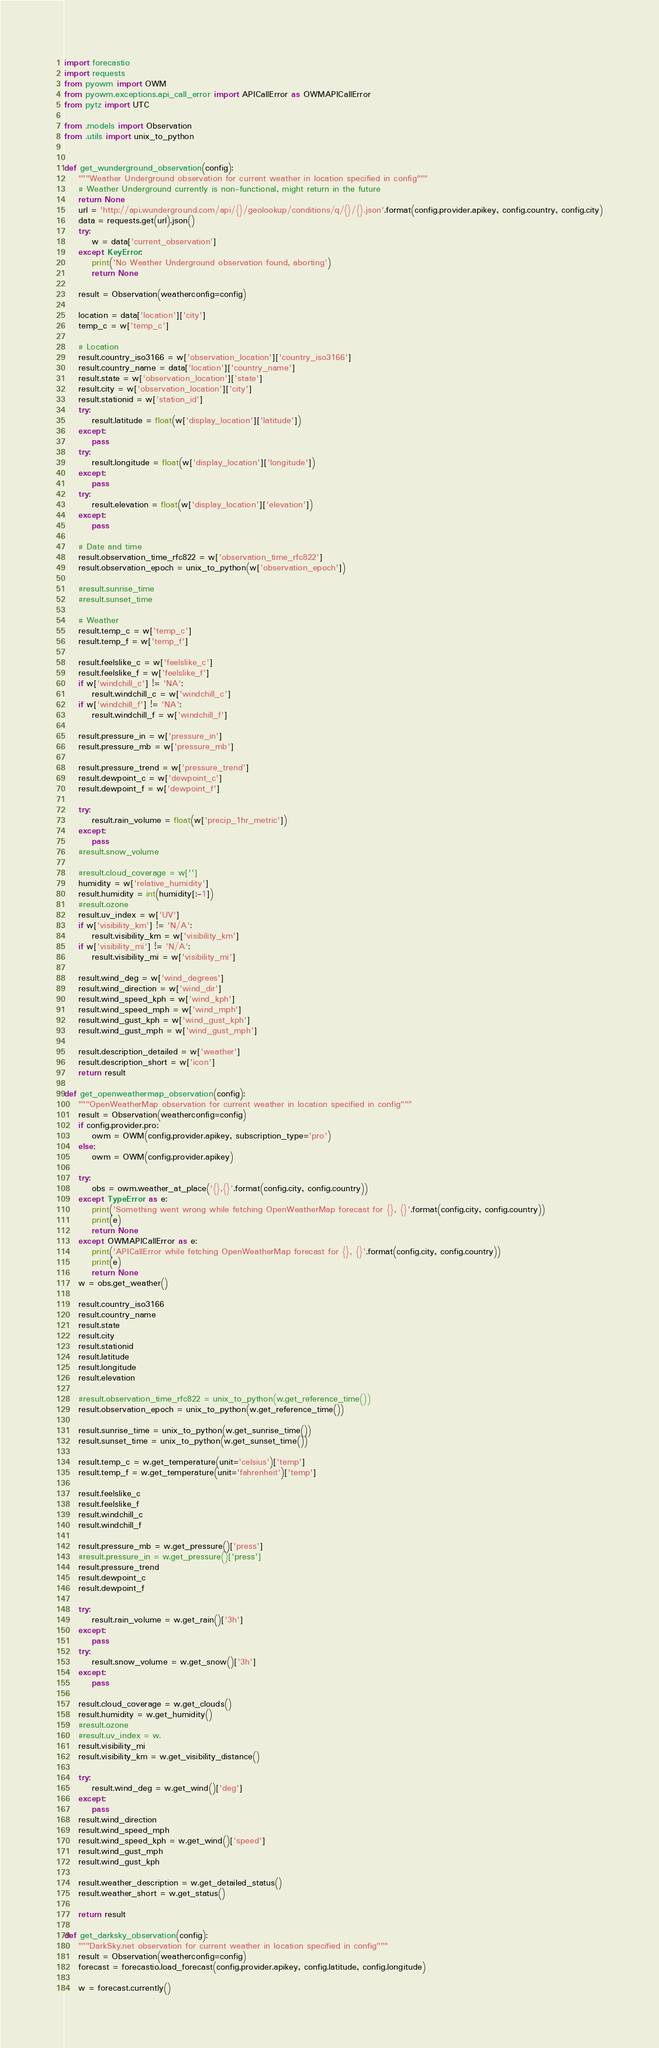Convert code to text. <code><loc_0><loc_0><loc_500><loc_500><_Python_>import forecastio
import requests
from pyowm import OWM
from pyowm.exceptions.api_call_error import APICallError as OWMAPICallError
from pytz import UTC

from .models import Observation
from .utils import unix_to_python


def get_wunderground_observation(config):
    """Weather Underground observation for current weather in location specified in config"""
    # Weather Underground currently is non-functional, might return in the future
    return None
    url = 'http://api.wunderground.com/api/{}/geolookup/conditions/q/{}/{}.json'.format(config.provider.apikey, config.country, config.city)
    data = requests.get(url).json()
    try:
        w = data['current_observation']
    except KeyError:
        print('No Weather Underground observation found, aborting')
        return None

    result = Observation(weatherconfig=config)

    location = data['location']['city']
    temp_c = w['temp_c']

    # Location
    result.country_iso3166 = w['observation_location']['country_iso3166']
    result.country_name = data['location']['country_name']
    result.state = w['observation_location']['state']
    result.city = w['observation_location']['city']
    result.stationid = w['station_id']
    try:
        result.latitude = float(w['display_location']['latitude'])
    except:
        pass
    try:
        result.longitude = float(w['display_location']['longitude'])
    except:
        pass
    try:
        result.elevation = float(w['display_location']['elevation'])
    except:
        pass

    # Date and time
    result.observation_time_rfc822 = w['observation_time_rfc822']
    result.observation_epoch = unix_to_python(w['observation_epoch'])

    #result.sunrise_time
    #result.sunset_time

    # Weather
    result.temp_c = w['temp_c']
    result.temp_f = w['temp_f']

    result.feelslike_c = w['feelslike_c']
    result.feelslike_f = w['feelslike_f']
    if w['windchill_c'] != 'NA':
        result.windchill_c = w['windchill_c']
    if w['windchill_f'] != 'NA':
        result.windchill_f = w['windchill_f']

    result.pressure_in = w['pressure_in']
    result.pressure_mb = w['pressure_mb']

    result.pressure_trend = w['pressure_trend']
    result.dewpoint_c = w['dewpoint_c']
    result.dewpoint_f = w['dewpoint_f']

    try:
        result.rain_volume = float(w['precip_1hr_metric'])
    except:
        pass
    #result.snow_volume

    #result.cloud_coverage = w['']
    humidity = w['relative_humidity']
    result.humidity = int(humidity[:-1])
    #result.ozone
    result.uv_index = w['UV']
    if w['visibility_km'] != 'N/A':
        result.visibility_km = w['visibility_km']
    if w['visibility_mi'] != 'N/A':
        result.visibility_mi = w['visibility_mi']

    result.wind_deg = w['wind_degrees']
    result.wind_direction = w['wind_dir']
    result.wind_speed_kph = w['wind_kph']
    result.wind_speed_mph = w['wind_mph']
    result.wind_gust_kph = w['wind_gust_kph']
    result.wind_gust_mph = w['wind_gust_mph']

    result.description_detailed = w['weather']
    result.description_short = w['icon']
    return result

def get_openweathermap_observation(config):
    """OpenWeatherMap observation for current weather in location specified in config"""
    result = Observation(weatherconfig=config)
    if config.provider.pro:
        owm = OWM(config.provider.apikey, subscription_type='pro')
    else:
        owm = OWM(config.provider.apikey)

    try:
        obs = owm.weather_at_place('{},{}'.format(config.city, config.country))
    except TypeError as e:
        print('Something went wrong while fetching OpenWeatherMap forecast for {}, {}'.format(config.city, config.country))
        print(e)
        return None
    except OWMAPICallError as e:
        print('APICallError while fetching OpenWeatherMap forecast for {}, {}'.format(config.city, config.country))
        print(e)
        return None
    w = obs.get_weather()

    result.country_iso3166
    result.country_name
    result.state
    result.city
    result.stationid
    result.latitude
    result.longitude
    result.elevation

    #result.observation_time_rfc822 = unix_to_python(w.get_reference_time())
    result.observation_epoch = unix_to_python(w.get_reference_time())

    result.sunrise_time = unix_to_python(w.get_sunrise_time())
    result.sunset_time = unix_to_python(w.get_sunset_time())

    result.temp_c = w.get_temperature(unit='celsius')['temp']
    result.temp_f = w.get_temperature(unit='fahrenheit')['temp']

    result.feelslike_c
    result.feelslike_f
    result.windchill_c
    result.windchill_f

    result.pressure_mb = w.get_pressure()['press']
    #result.pressure_in = w.get_pressure()['press']
    result.pressure_trend
    result.dewpoint_c
    result.dewpoint_f

    try:
        result.rain_volume = w.get_rain()['3h']
    except:
        pass
    try:
        result.snow_volume = w.get_snow()['3h']
    except:
        pass

    result.cloud_coverage = w.get_clouds()
    result.humidity = w.get_humidity()
    #result.ozone
    #result.uv_index = w.
    result.visibility_mi
    result.visibility_km = w.get_visibility_distance()

    try:
        result.wind_deg = w.get_wind()['deg']
    except:
        pass
    result.wind_direction
    result.wind_speed_mph
    result.wind_speed_kph = w.get_wind()['speed']
    result.wind_gust_mph
    result.wind_gust_kph

    result.weather_description = w.get_detailed_status()
    result.weather_short = w.get_status()

    return result

def get_darksky_observation(config):
    """DarkSky.net observation for current weather in location specified in config"""
    result = Observation(weatherconfig=config)
    forecast = forecastio.load_forecast(config.provider.apikey, config.latitude, config.longitude)

    w = forecast.currently()</code> 